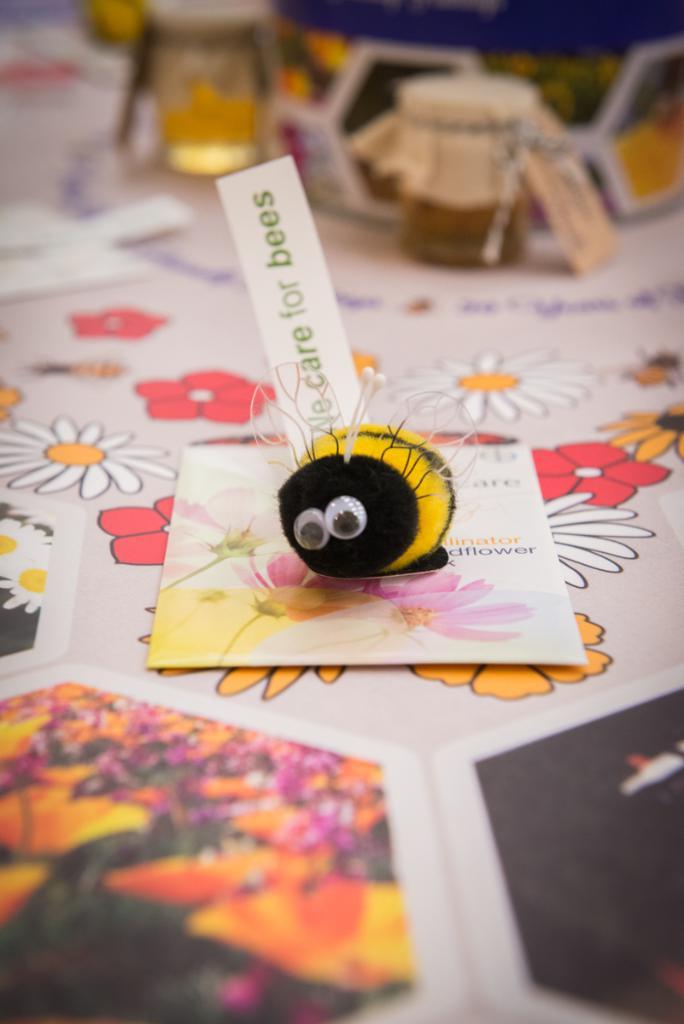What do we care for?
Offer a terse response. Bees. What insect is on the table?
Your response must be concise. Bee. 